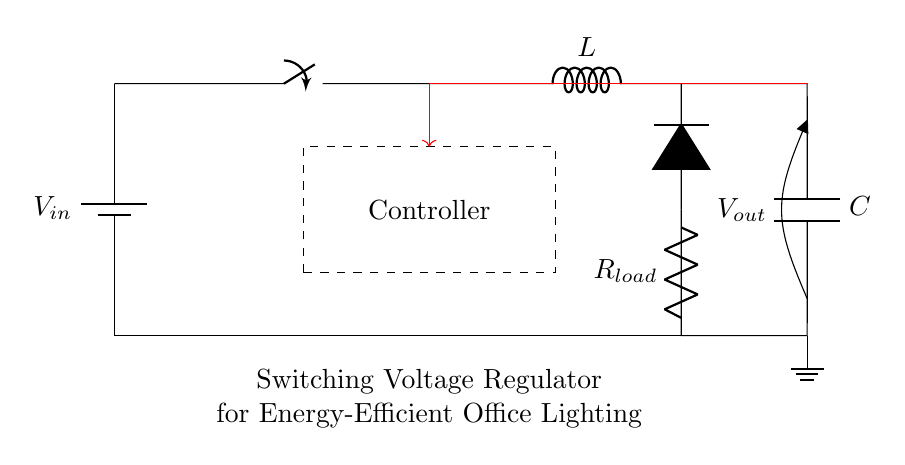What is the input component of the circuit? The input component is a battery, as indicated at the start of the circuit diagram. It provides the power source for the switching voltage regulator.
Answer: battery What is the function of the switch in this circuit? The switch controls the flow of current, allowing the circuit to turn on or off as needed. When closed, it enables current to flow from the input to the other components.
Answer: control current What type of regulator is depicted in this diagram? The diagram illustrates a switching voltage regulator, which is designed for efficient energy conversion and maintaining output voltage levels.
Answer: switching What does the load represent in this circuit? The load, represented by the resistor labeled R load, indicates the component that consumes power from the regulated output of the circuit.
Answer: lighting system What is the purpose of the inductor in this circuit? The inductor stores energy when current flows through it and helps in maintaining a stable output by smoothing the current when combined with the capacitor.
Answer: energy storage How does the feedback mechanism work in this regulator? The feedback mechanism with the red arrow indicates that the output voltage is monitored and sent back to the controller to adjust the regulation process, ensuring stable output.
Answer: monitors voltage What is the relationship between the capacitor and the load? The capacitor works in conjunction with the load to filter the output voltage, smoothing out voltage fluctuations for more stable performance.
Answer: stabilizes voltage 